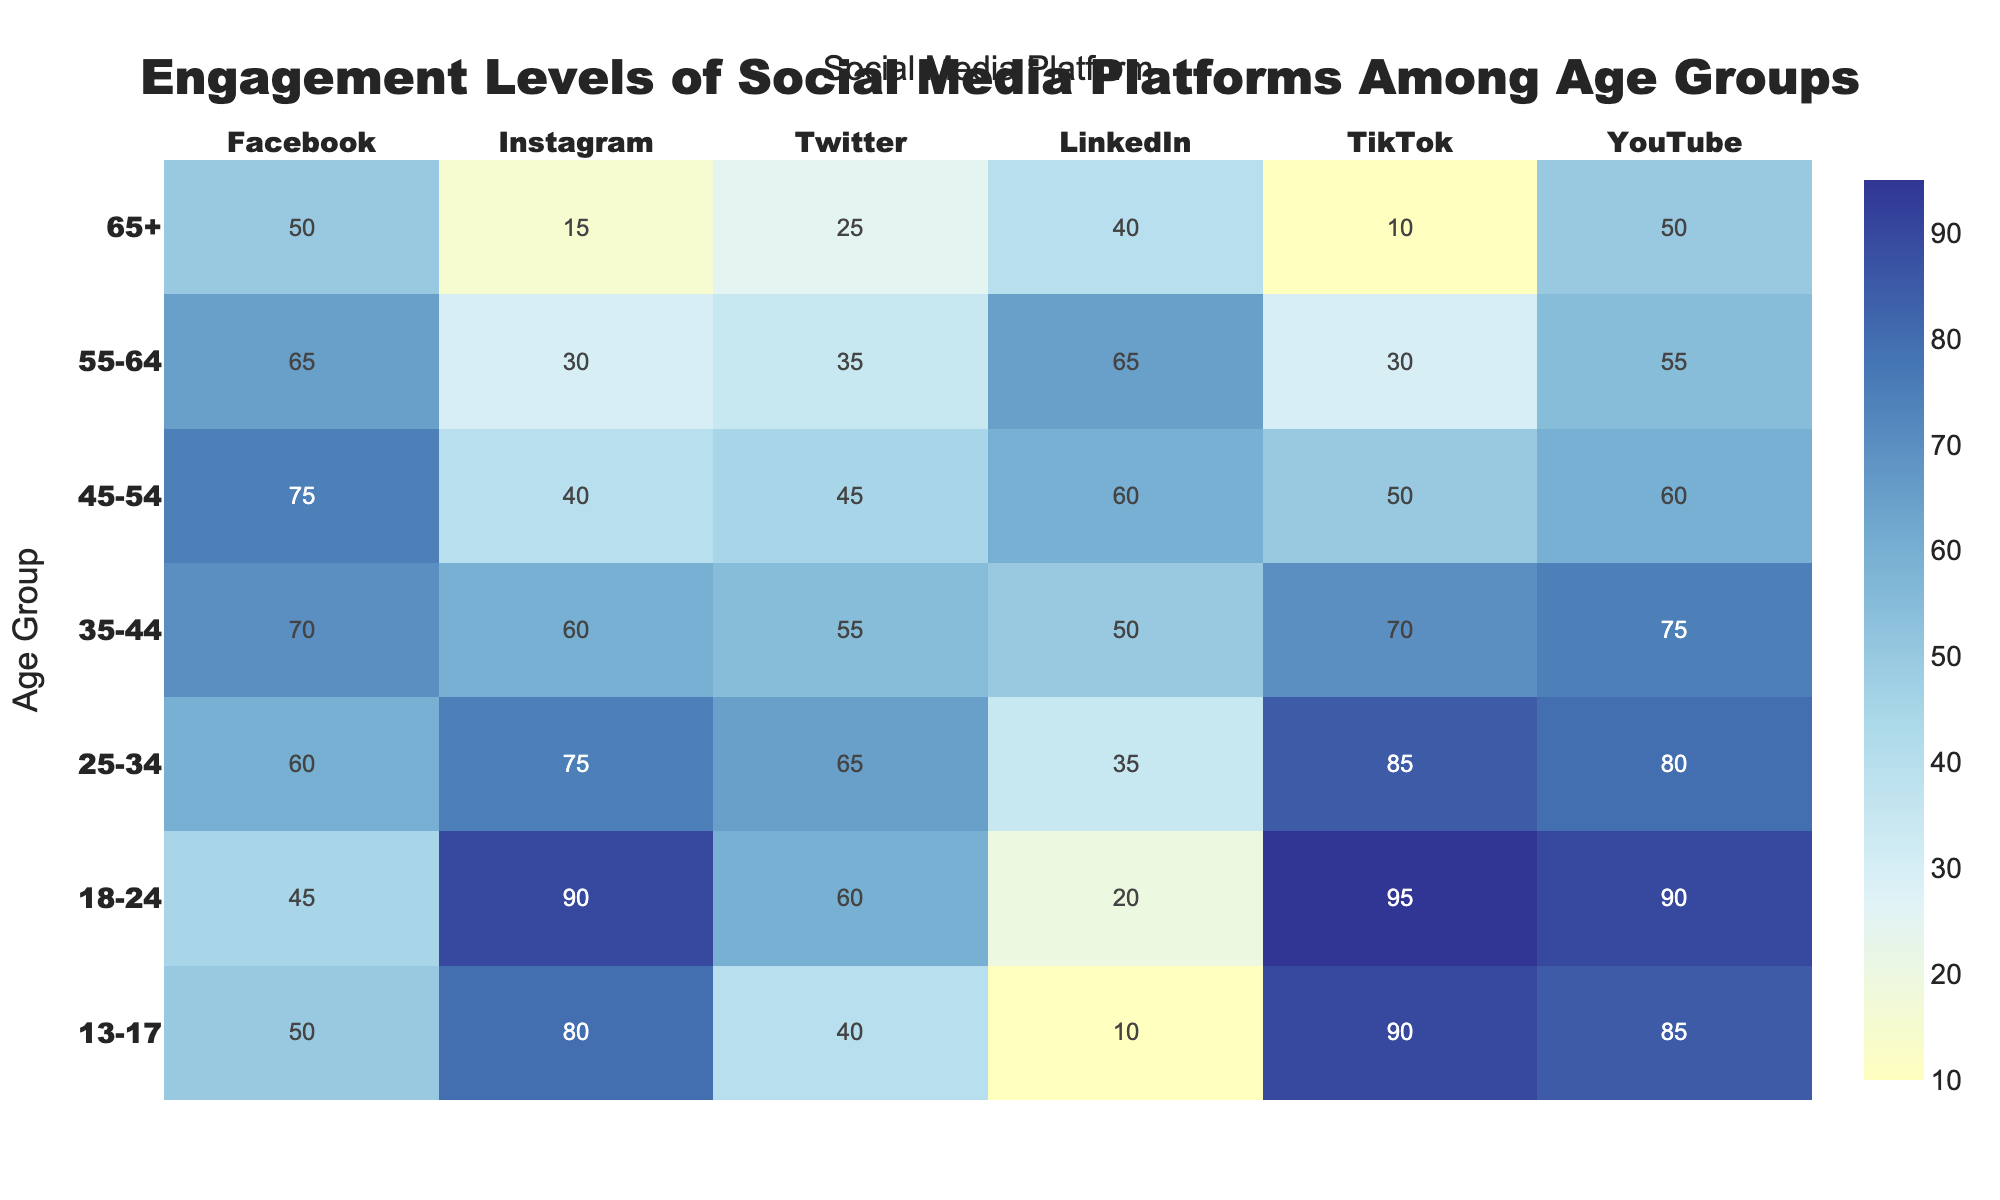What's the title of the heatmap? The title is at the top center of the heatmap, colored in black, stating the primary focus of the visualization.
Answer: Engagement Levels of Social Media Platforms Among Age Groups Which age group has the highest engagement level on Instagram? Look down the Instagram column to find the age group with the highest number, which is in the range 18-24 and the engagement level is 90.
Answer: 18-24 How does engagement on TikTok differ between the 13-17 and 65+ age groups? Compare the values for the two age groups in the TikTok column, where 90 (13-17) and 10 (65+). Subtracting the smaller value from the larger provides the difference. 90 - 10 = 80
Answer: 80 What is the average engagement level for Facebook across all age groups? Sum the engagement values for Facebook across all age groups and divide by the total number of age groups. (50 + 45 + 60 + 70 + 75 + 65 + 50) / 7 = 58.57
Answer: 58.57 Which social media platform has the most varied engagement levels across different age groups? Assess the range of values for each platform's column to find the widest difference between the minimum and maximum values. Facebook ranges from 45 to 75, Instagram ranges from 15 to 90, TikTok ranges from 10 to 95, etc.
Answer: TikTok Is engagement level in YouTube generally increasing or decreasing with age? Examine the values in the YouTube column from top (13-17) to bottom (65+), noting whether numbers generally rise or fall. The engagement tends to decrease from 85 to 50 as age increases.
Answer: Decreasing What is the total engagement level for LinkedIn in the 25-34 and 35-44 age groups combined? Add together the engagement values for LinkedIn in the 25-34 and 35-44 age groups. 35 (25-34) + 50 (35-44) = 85
Answer: 85 Which social media platform has the highest engagement among the 55-64 age group? Identify the maximum engagement value within the 55-64 row. The highest is 65 for LinkedIn.
Answer: LinkedIn Does Twitter engagement surpass 50 in any age group? Scan the Twitter column for any values above 50. The 18-24 (60) and 25-34 (65) age groups have engagement levels surpassing 50.
Answer: Yes Are engagement levels for Facebook and Instagram generally positively correlated across age groups? Compare the values in the Facebook and Instagram columns for each age group to see if they both increase or decrease together. For many age groups, both rise positively except for small variations.
Answer: Yes 